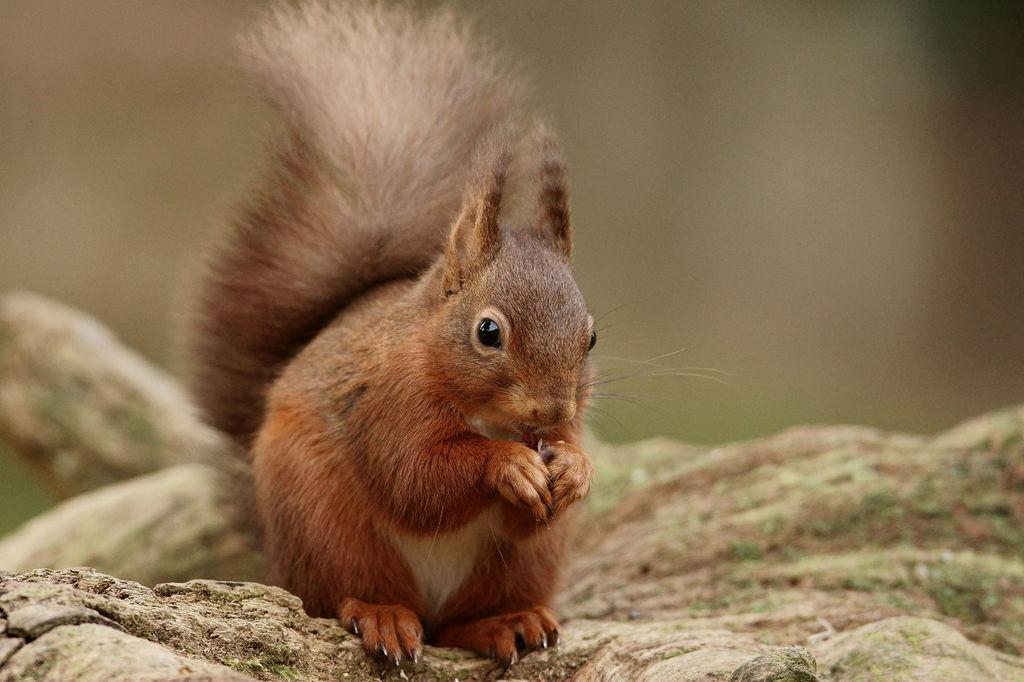What animal is present in the image? There is a squirrel in the image. What is the squirrel standing on? The squirrel is standing on a rock surface. Can you describe the background of the image? The background of the image appears blurry. What note can be seen in the squirrel's stomach in the image? There is no note visible in the image, and the squirrel's stomach is not mentioned in the provided facts. Who is the friend of the squirrel in the image? There is no mention of a friend in the image or the provided facts. 